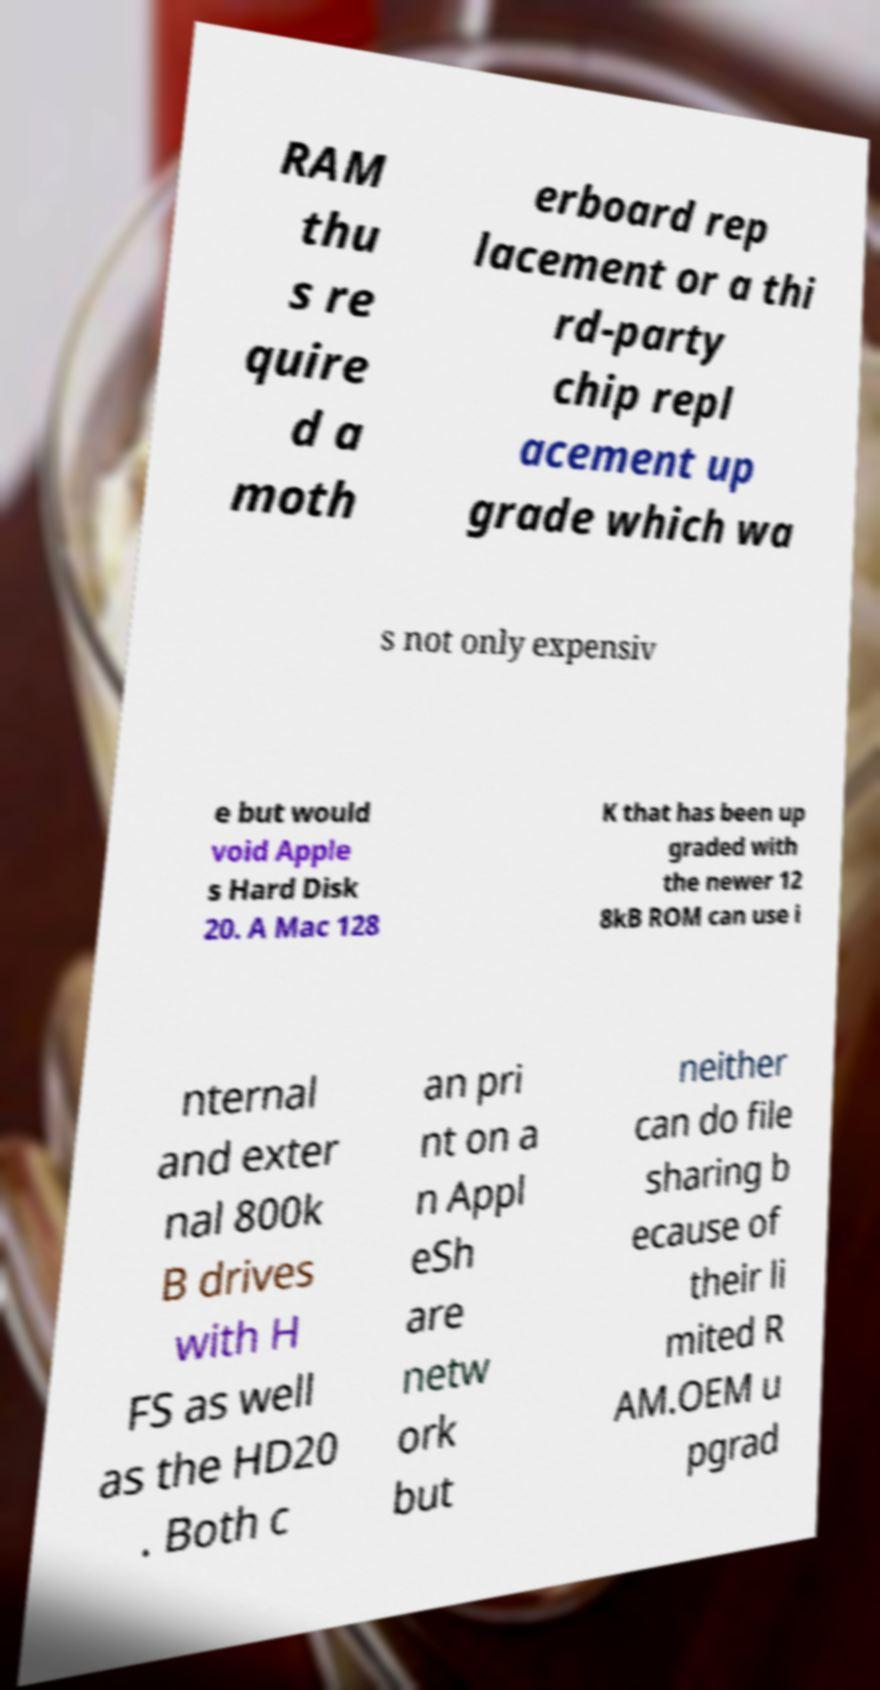I need the written content from this picture converted into text. Can you do that? RAM thu s re quire d a moth erboard rep lacement or a thi rd-party chip repl acement up grade which wa s not only expensiv e but would void Apple s Hard Disk 20. A Mac 128 K that has been up graded with the newer 12 8kB ROM can use i nternal and exter nal 800k B drives with H FS as well as the HD20 . Both c an pri nt on a n Appl eSh are netw ork but neither can do file sharing b ecause of their li mited R AM.OEM u pgrad 